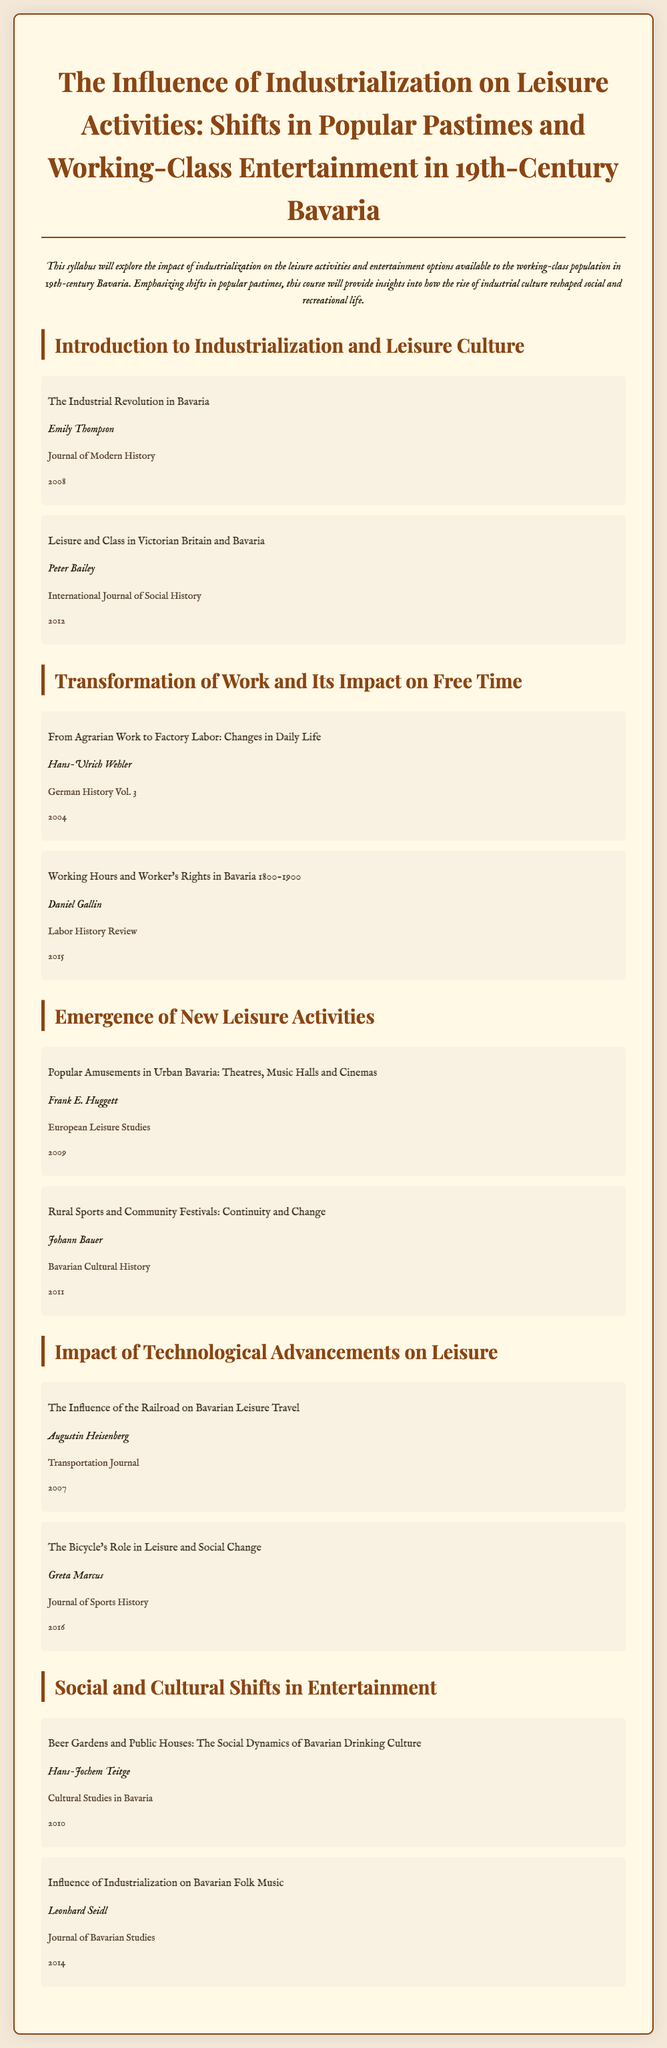What is the title of the syllabus? The title is mentioned at the top of the document, indicating the subject of the syllabus.
Answer: The Influence of Industrialization on Leisure Activities: Shifts in Popular Pastimes and Working-Class Entertainment in 19th-Century Bavaria Who is the author of the reading titled "Beer Gardens and Public Houses: The Social Dynamics of Bavarian Drinking Culture"? The author's name is specified under the title of the reading in the syllabus.
Answer: Hans-Jochem Teitge How many sections are there in the syllabus? The number of sections can be counted based on the headings in the document.
Answer: Five What year was "The Industrial Revolution in Bavaria" published? The publication year is located after the author's name in the readings section.
Answer: 2008 Which reading discusses the influence of the bicycle? The reading titles provide details about their content, allowing for specific identification.
Answer: The Bicycle's Role in Leisure and Social Change What is a focus of the section titled "Emergence of New Leisure Activities"? The main themes of this section can be inferred from the titles of the readings included within it.
Answer: Popular Amusements and Rural Sports In which journal was "Working Hours and Worker's Rights in Bavaria 1800-1900" published? The source journal is listed under the reading information, indicating where it can be found.
Answer: Labor History Review Who authored the reading about Bavarian Folk Music? The author is clearly identified under the reading title, providing a direct source link.
Answer: Leonhard Seidl Which author's work addresses changes in daily life due to the transition from agrarian work to factory labor? The readings list provides information on who wrote about specific topics, leading to this identification.
Answer: Hans-Ulrich Wehler 